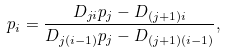<formula> <loc_0><loc_0><loc_500><loc_500>p _ { i } = \frac { D _ { j i } p _ { j } - D _ { ( j + 1 ) i } } { D _ { j ( i - 1 ) } p _ { j } - D _ { ( j + 1 ) ( i - 1 ) } } ,</formula> 